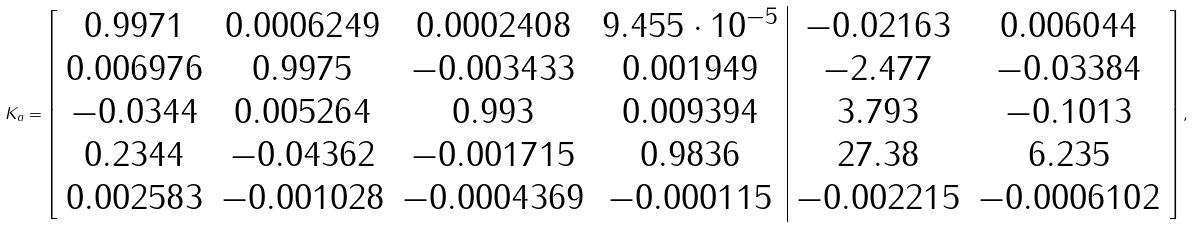Convert formula to latex. <formula><loc_0><loc_0><loc_500><loc_500>K _ { a } = \left [ \begin{array} { c c c c | c c } 0 . 9 9 7 1 & 0 . 0 0 0 6 2 4 9 & 0 . 0 0 0 2 4 0 8 & 9 . 4 5 5 \cdot 1 0 ^ { - 5 } & - 0 . 0 2 1 6 3 & 0 . 0 0 6 0 4 4 \\ 0 . 0 0 6 9 7 6 & 0 . 9 9 7 5 & - 0 . 0 0 3 4 3 3 & 0 . 0 0 1 9 4 9 & - 2 . 4 7 7 & - 0 . 0 3 3 8 4 \\ - 0 . 0 3 4 4 & 0 . 0 0 5 2 6 4 & 0 . 9 9 3 & 0 . 0 0 9 3 9 4 & 3 . 7 9 3 & - 0 . 1 0 1 3 \\ 0 . 2 3 4 4 & - 0 . 0 4 3 6 2 & - 0 . 0 0 1 7 1 5 & 0 . 9 8 3 6 & 2 7 . 3 8 & 6 . 2 3 5 \\ 0 . 0 0 2 5 8 3 & - 0 . 0 0 1 0 2 8 & - 0 . 0 0 0 4 3 6 9 & - 0 . 0 0 0 1 1 5 & - 0 . 0 0 2 2 1 5 & - 0 . 0 0 0 6 1 0 2 \end{array} \right ] ,</formula> 